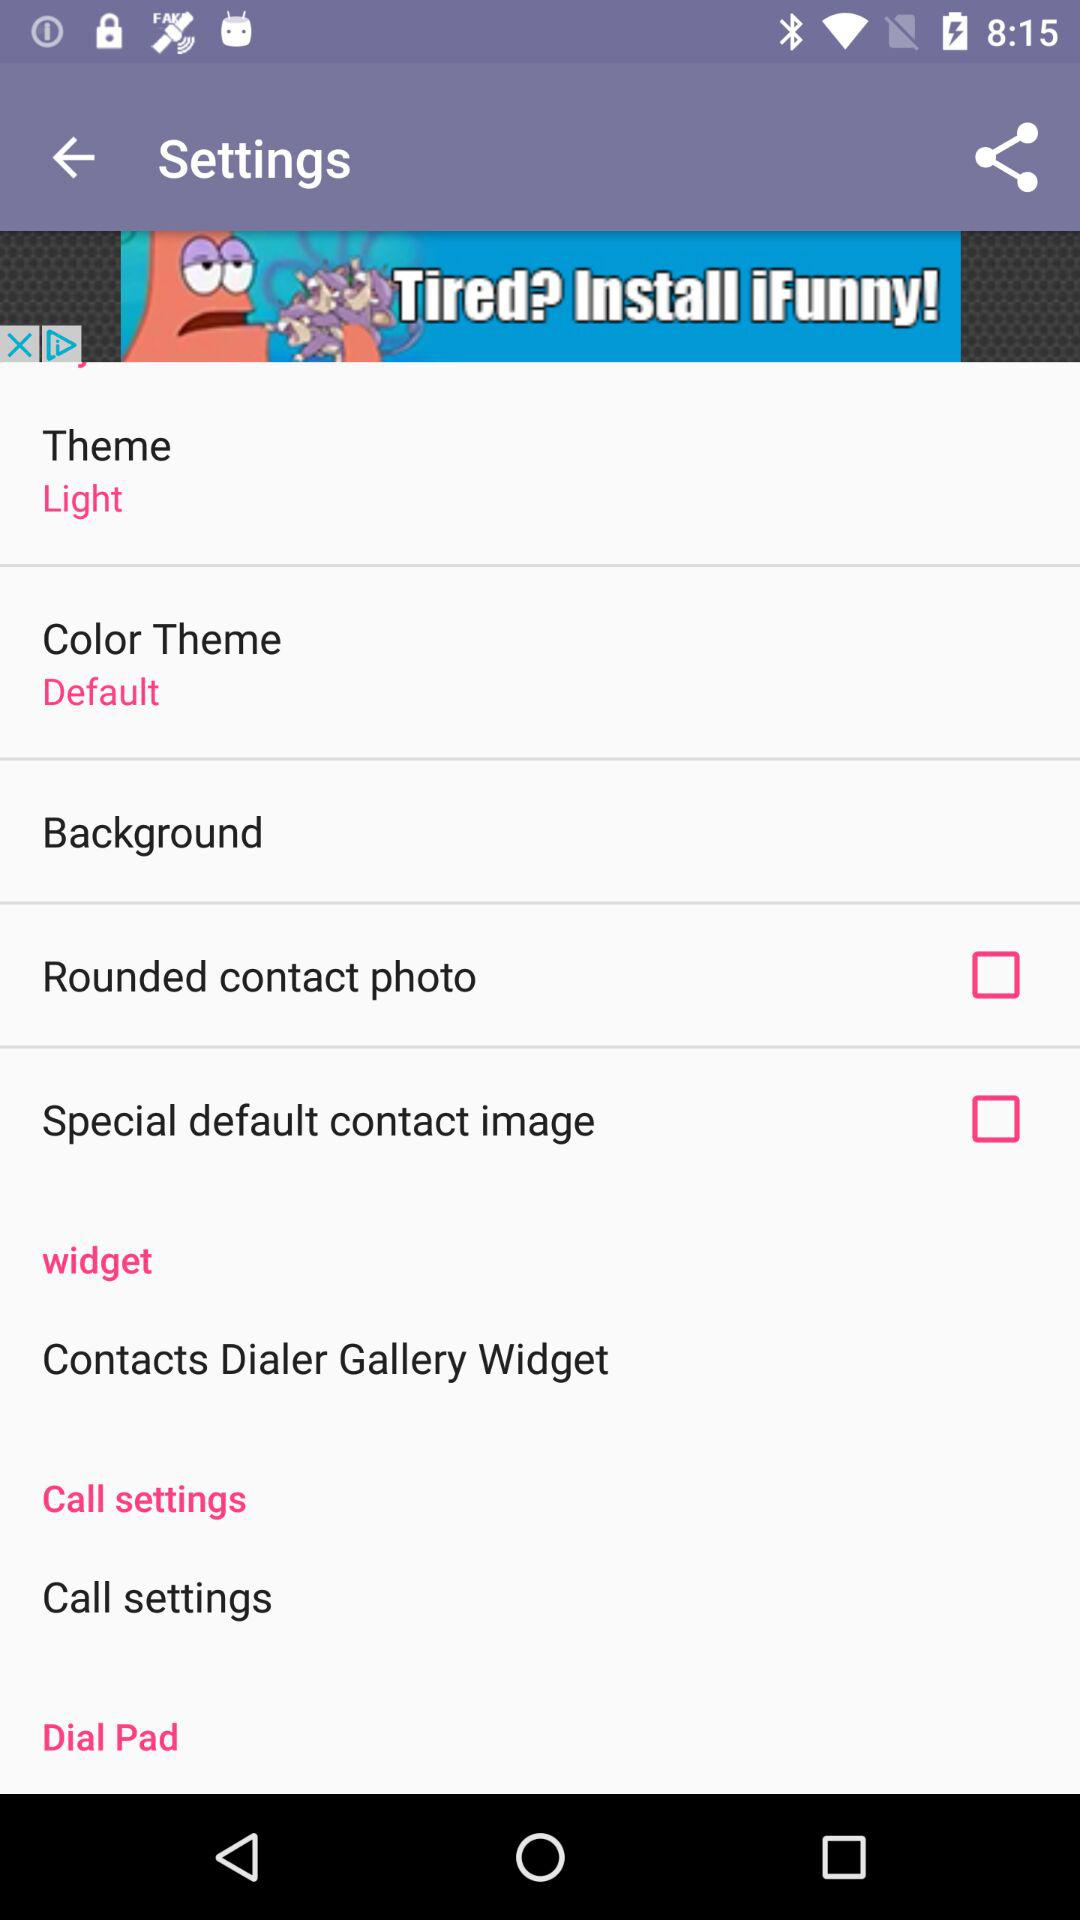Is "Background" checked or unchecked?
When the provided information is insufficient, respond with <no answer>. <no answer> 